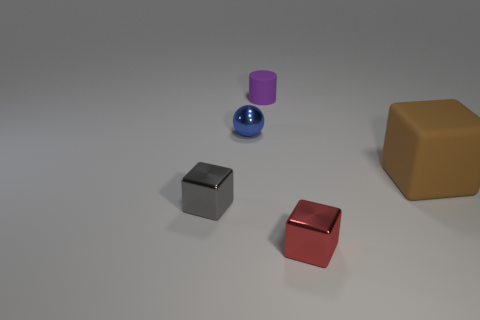Add 1 tiny purple matte cubes. How many objects exist? 6 Subtract all cylinders. How many objects are left? 4 Subtract all red metallic balls. Subtract all big brown objects. How many objects are left? 4 Add 4 small cylinders. How many small cylinders are left? 5 Add 3 small brown cubes. How many small brown cubes exist? 3 Subtract 0 brown cylinders. How many objects are left? 5 